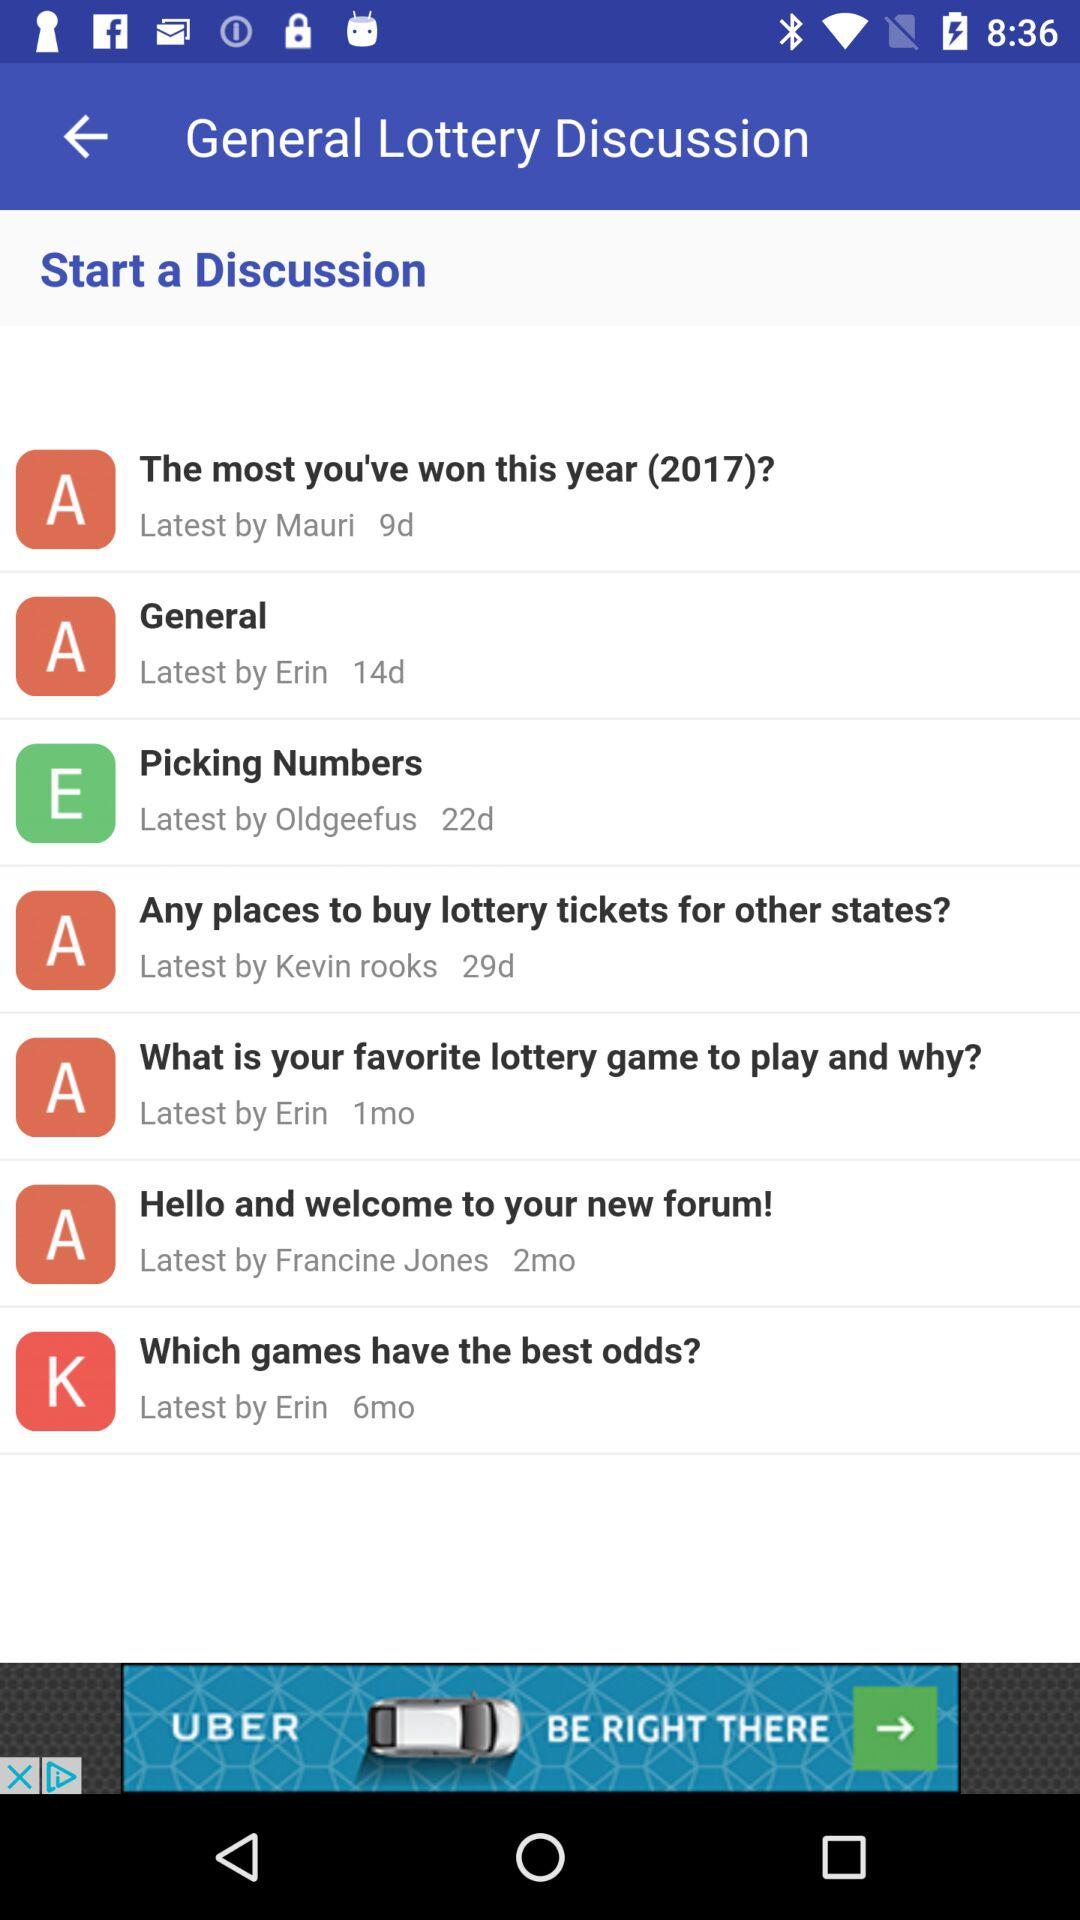Kevin Rooks starts the discussion on which topic? Kevin Rooks starts the discussion on the topic "Any places to buy lottery tickets for other states?". 